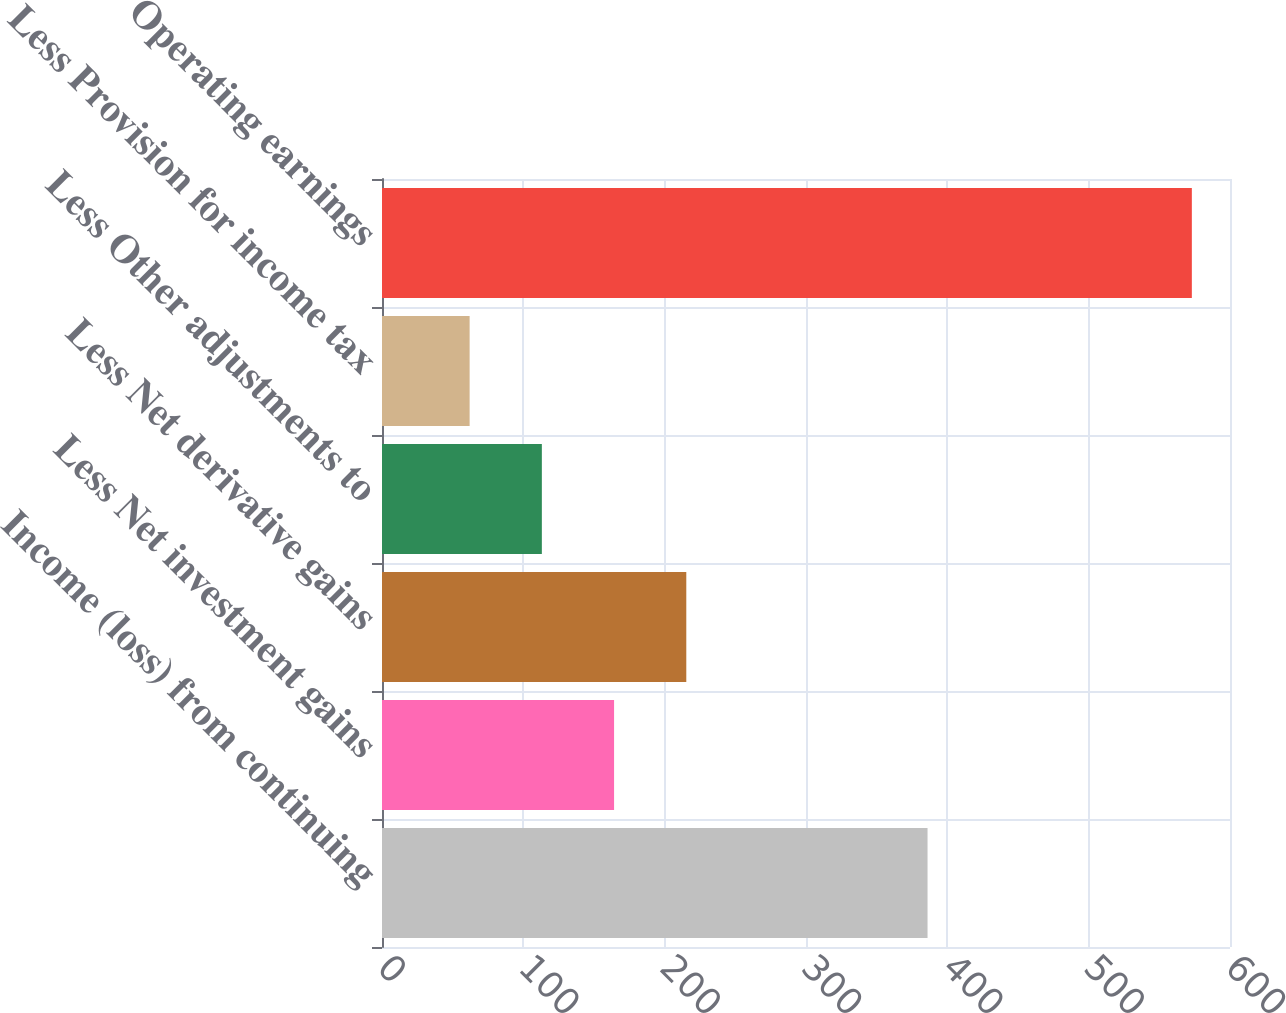Convert chart to OTSL. <chart><loc_0><loc_0><loc_500><loc_500><bar_chart><fcel>Income (loss) from continuing<fcel>Less Net investment gains<fcel>Less Net derivative gains<fcel>Less Other adjustments to<fcel>Less Provision for income tax<fcel>Operating earnings<nl><fcel>386<fcel>164.2<fcel>215.3<fcel>113.1<fcel>62<fcel>573<nl></chart> 